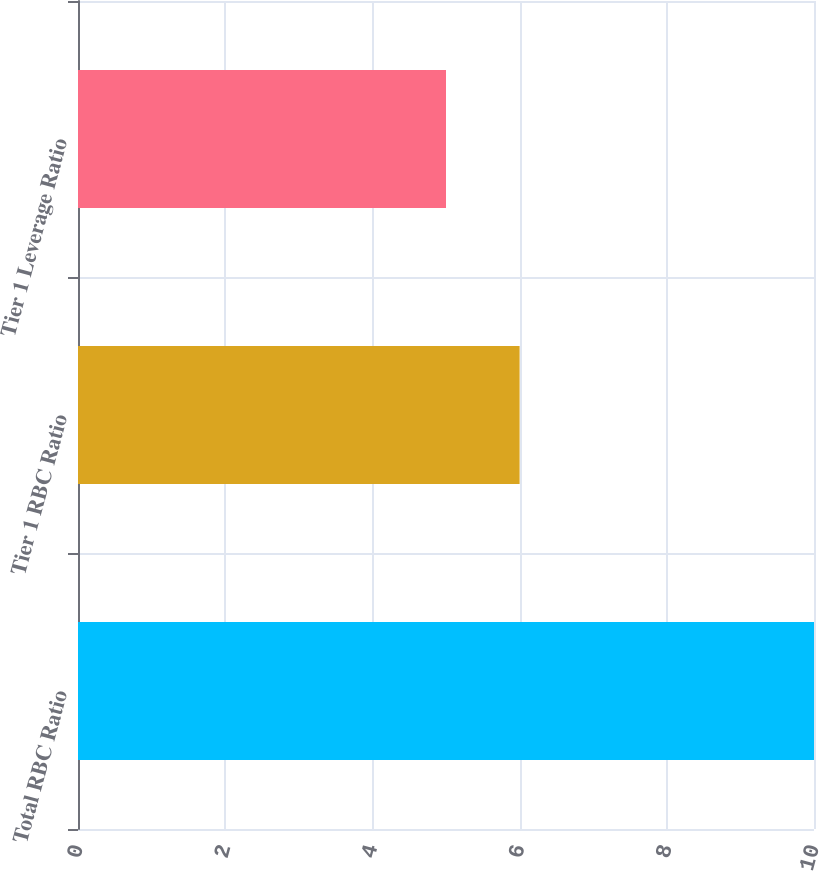<chart> <loc_0><loc_0><loc_500><loc_500><bar_chart><fcel>Total RBC Ratio<fcel>Tier 1 RBC Ratio<fcel>Tier 1 Leverage Ratio<nl><fcel>10<fcel>6<fcel>5<nl></chart> 